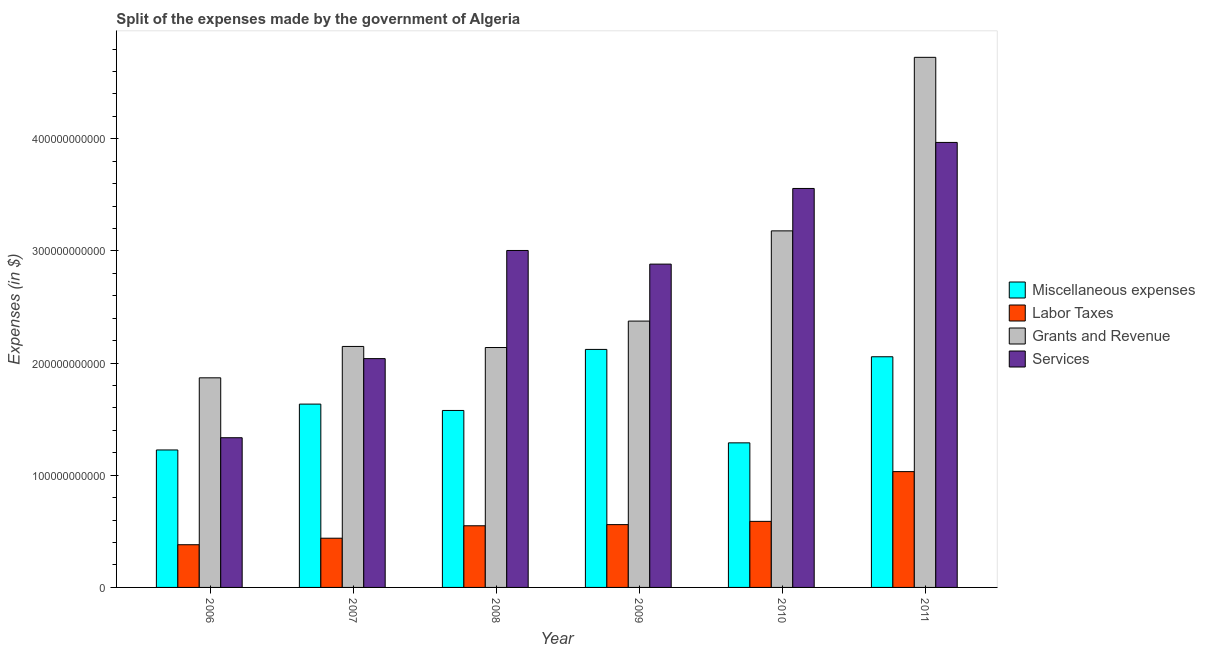How many different coloured bars are there?
Your response must be concise. 4. Are the number of bars per tick equal to the number of legend labels?
Make the answer very short. Yes. How many bars are there on the 5th tick from the left?
Your response must be concise. 4. What is the amount spent on labor taxes in 2008?
Your answer should be very brief. 5.50e+1. Across all years, what is the maximum amount spent on labor taxes?
Offer a terse response. 1.03e+11. Across all years, what is the minimum amount spent on grants and revenue?
Provide a short and direct response. 1.87e+11. What is the total amount spent on services in the graph?
Provide a short and direct response. 1.68e+12. What is the difference between the amount spent on miscellaneous expenses in 2008 and that in 2011?
Your answer should be very brief. -4.79e+1. What is the difference between the amount spent on labor taxes in 2008 and the amount spent on services in 2009?
Give a very brief answer. -1.03e+09. What is the average amount spent on services per year?
Make the answer very short. 2.80e+11. In how many years, is the amount spent on labor taxes greater than 220000000000 $?
Ensure brevity in your answer.  0. What is the ratio of the amount spent on labor taxes in 2007 to that in 2011?
Keep it short and to the point. 0.43. Is the difference between the amount spent on labor taxes in 2007 and 2009 greater than the difference between the amount spent on miscellaneous expenses in 2007 and 2009?
Your response must be concise. No. What is the difference between the highest and the second highest amount spent on grants and revenue?
Your answer should be very brief. 1.55e+11. What is the difference between the highest and the lowest amount spent on labor taxes?
Give a very brief answer. 6.52e+1. What does the 2nd bar from the left in 2010 represents?
Give a very brief answer. Labor Taxes. What does the 3rd bar from the right in 2006 represents?
Keep it short and to the point. Labor Taxes. Is it the case that in every year, the sum of the amount spent on miscellaneous expenses and amount spent on labor taxes is greater than the amount spent on grants and revenue?
Your answer should be very brief. No. Are all the bars in the graph horizontal?
Offer a very short reply. No. How many years are there in the graph?
Provide a succinct answer. 6. What is the difference between two consecutive major ticks on the Y-axis?
Keep it short and to the point. 1.00e+11. Where does the legend appear in the graph?
Offer a terse response. Center right. What is the title of the graph?
Make the answer very short. Split of the expenses made by the government of Algeria. Does "Argument" appear as one of the legend labels in the graph?
Offer a terse response. No. What is the label or title of the Y-axis?
Your answer should be compact. Expenses (in $). What is the Expenses (in $) in Miscellaneous expenses in 2006?
Your response must be concise. 1.23e+11. What is the Expenses (in $) of Labor Taxes in 2006?
Offer a terse response. 3.81e+1. What is the Expenses (in $) of Grants and Revenue in 2006?
Give a very brief answer. 1.87e+11. What is the Expenses (in $) of Services in 2006?
Keep it short and to the point. 1.33e+11. What is the Expenses (in $) of Miscellaneous expenses in 2007?
Offer a terse response. 1.63e+11. What is the Expenses (in $) of Labor Taxes in 2007?
Offer a very short reply. 4.39e+1. What is the Expenses (in $) in Grants and Revenue in 2007?
Give a very brief answer. 2.15e+11. What is the Expenses (in $) of Services in 2007?
Provide a succinct answer. 2.04e+11. What is the Expenses (in $) of Miscellaneous expenses in 2008?
Offer a very short reply. 1.58e+11. What is the Expenses (in $) of Labor Taxes in 2008?
Your response must be concise. 5.50e+1. What is the Expenses (in $) of Grants and Revenue in 2008?
Provide a succinct answer. 2.14e+11. What is the Expenses (in $) in Services in 2008?
Give a very brief answer. 3.00e+11. What is the Expenses (in $) in Miscellaneous expenses in 2009?
Your answer should be compact. 2.12e+11. What is the Expenses (in $) of Labor Taxes in 2009?
Ensure brevity in your answer.  5.60e+1. What is the Expenses (in $) in Grants and Revenue in 2009?
Your answer should be compact. 2.37e+11. What is the Expenses (in $) in Services in 2009?
Offer a very short reply. 2.88e+11. What is the Expenses (in $) in Miscellaneous expenses in 2010?
Keep it short and to the point. 1.29e+11. What is the Expenses (in $) of Labor Taxes in 2010?
Your response must be concise. 5.89e+1. What is the Expenses (in $) of Grants and Revenue in 2010?
Provide a short and direct response. 3.18e+11. What is the Expenses (in $) of Services in 2010?
Your answer should be compact. 3.56e+11. What is the Expenses (in $) in Miscellaneous expenses in 2011?
Offer a very short reply. 2.06e+11. What is the Expenses (in $) in Labor Taxes in 2011?
Give a very brief answer. 1.03e+11. What is the Expenses (in $) of Grants and Revenue in 2011?
Provide a short and direct response. 4.73e+11. What is the Expenses (in $) of Services in 2011?
Make the answer very short. 3.97e+11. Across all years, what is the maximum Expenses (in $) in Miscellaneous expenses?
Your answer should be compact. 2.12e+11. Across all years, what is the maximum Expenses (in $) of Labor Taxes?
Offer a very short reply. 1.03e+11. Across all years, what is the maximum Expenses (in $) of Grants and Revenue?
Give a very brief answer. 4.73e+11. Across all years, what is the maximum Expenses (in $) in Services?
Keep it short and to the point. 3.97e+11. Across all years, what is the minimum Expenses (in $) of Miscellaneous expenses?
Make the answer very short. 1.23e+11. Across all years, what is the minimum Expenses (in $) in Labor Taxes?
Your answer should be compact. 3.81e+1. Across all years, what is the minimum Expenses (in $) of Grants and Revenue?
Provide a succinct answer. 1.87e+11. Across all years, what is the minimum Expenses (in $) of Services?
Make the answer very short. 1.33e+11. What is the total Expenses (in $) of Miscellaneous expenses in the graph?
Offer a terse response. 9.91e+11. What is the total Expenses (in $) of Labor Taxes in the graph?
Ensure brevity in your answer.  3.55e+11. What is the total Expenses (in $) in Grants and Revenue in the graph?
Your response must be concise. 1.64e+12. What is the total Expenses (in $) of Services in the graph?
Provide a short and direct response. 1.68e+12. What is the difference between the Expenses (in $) in Miscellaneous expenses in 2006 and that in 2007?
Offer a very short reply. -4.09e+1. What is the difference between the Expenses (in $) of Labor Taxes in 2006 and that in 2007?
Offer a terse response. -5.81e+09. What is the difference between the Expenses (in $) in Grants and Revenue in 2006 and that in 2007?
Your answer should be compact. -2.80e+1. What is the difference between the Expenses (in $) in Services in 2006 and that in 2007?
Provide a succinct answer. -7.05e+1. What is the difference between the Expenses (in $) of Miscellaneous expenses in 2006 and that in 2008?
Offer a very short reply. -3.52e+1. What is the difference between the Expenses (in $) in Labor Taxes in 2006 and that in 2008?
Keep it short and to the point. -1.69e+1. What is the difference between the Expenses (in $) of Grants and Revenue in 2006 and that in 2008?
Give a very brief answer. -2.70e+1. What is the difference between the Expenses (in $) in Services in 2006 and that in 2008?
Offer a terse response. -1.67e+11. What is the difference between the Expenses (in $) in Miscellaneous expenses in 2006 and that in 2009?
Give a very brief answer. -8.96e+1. What is the difference between the Expenses (in $) in Labor Taxes in 2006 and that in 2009?
Offer a terse response. -1.79e+1. What is the difference between the Expenses (in $) of Grants and Revenue in 2006 and that in 2009?
Keep it short and to the point. -5.06e+1. What is the difference between the Expenses (in $) of Services in 2006 and that in 2009?
Keep it short and to the point. -1.55e+11. What is the difference between the Expenses (in $) of Miscellaneous expenses in 2006 and that in 2010?
Keep it short and to the point. -6.34e+09. What is the difference between the Expenses (in $) in Labor Taxes in 2006 and that in 2010?
Keep it short and to the point. -2.08e+1. What is the difference between the Expenses (in $) of Grants and Revenue in 2006 and that in 2010?
Offer a terse response. -1.31e+11. What is the difference between the Expenses (in $) of Services in 2006 and that in 2010?
Give a very brief answer. -2.22e+11. What is the difference between the Expenses (in $) of Miscellaneous expenses in 2006 and that in 2011?
Your answer should be compact. -8.31e+1. What is the difference between the Expenses (in $) in Labor Taxes in 2006 and that in 2011?
Provide a succinct answer. -6.52e+1. What is the difference between the Expenses (in $) in Grants and Revenue in 2006 and that in 2011?
Your response must be concise. -2.86e+11. What is the difference between the Expenses (in $) of Services in 2006 and that in 2011?
Give a very brief answer. -2.63e+11. What is the difference between the Expenses (in $) in Miscellaneous expenses in 2007 and that in 2008?
Offer a very short reply. 5.66e+09. What is the difference between the Expenses (in $) of Labor Taxes in 2007 and that in 2008?
Ensure brevity in your answer.  -1.11e+1. What is the difference between the Expenses (in $) in Grants and Revenue in 2007 and that in 2008?
Provide a succinct answer. 9.60e+08. What is the difference between the Expenses (in $) of Services in 2007 and that in 2008?
Your response must be concise. -9.64e+1. What is the difference between the Expenses (in $) in Miscellaneous expenses in 2007 and that in 2009?
Your answer should be compact. -4.88e+1. What is the difference between the Expenses (in $) of Labor Taxes in 2007 and that in 2009?
Keep it short and to the point. -1.21e+1. What is the difference between the Expenses (in $) of Grants and Revenue in 2007 and that in 2009?
Offer a very short reply. -2.26e+1. What is the difference between the Expenses (in $) of Services in 2007 and that in 2009?
Provide a succinct answer. -8.43e+1. What is the difference between the Expenses (in $) in Miscellaneous expenses in 2007 and that in 2010?
Give a very brief answer. 3.45e+1. What is the difference between the Expenses (in $) of Labor Taxes in 2007 and that in 2010?
Make the answer very short. -1.50e+1. What is the difference between the Expenses (in $) of Grants and Revenue in 2007 and that in 2010?
Your answer should be compact. -1.03e+11. What is the difference between the Expenses (in $) in Services in 2007 and that in 2010?
Your answer should be compact. -1.52e+11. What is the difference between the Expenses (in $) of Miscellaneous expenses in 2007 and that in 2011?
Your answer should be very brief. -4.22e+1. What is the difference between the Expenses (in $) in Labor Taxes in 2007 and that in 2011?
Offer a very short reply. -5.94e+1. What is the difference between the Expenses (in $) of Grants and Revenue in 2007 and that in 2011?
Your answer should be very brief. -2.58e+11. What is the difference between the Expenses (in $) of Services in 2007 and that in 2011?
Offer a terse response. -1.93e+11. What is the difference between the Expenses (in $) in Miscellaneous expenses in 2008 and that in 2009?
Provide a short and direct response. -5.44e+1. What is the difference between the Expenses (in $) of Labor Taxes in 2008 and that in 2009?
Ensure brevity in your answer.  -1.03e+09. What is the difference between the Expenses (in $) of Grants and Revenue in 2008 and that in 2009?
Offer a very short reply. -2.36e+1. What is the difference between the Expenses (in $) of Services in 2008 and that in 2009?
Offer a very short reply. 1.22e+1. What is the difference between the Expenses (in $) of Miscellaneous expenses in 2008 and that in 2010?
Give a very brief answer. 2.89e+1. What is the difference between the Expenses (in $) in Labor Taxes in 2008 and that in 2010?
Provide a succinct answer. -3.93e+09. What is the difference between the Expenses (in $) of Grants and Revenue in 2008 and that in 2010?
Make the answer very short. -1.04e+11. What is the difference between the Expenses (in $) of Services in 2008 and that in 2010?
Offer a terse response. -5.53e+1. What is the difference between the Expenses (in $) of Miscellaneous expenses in 2008 and that in 2011?
Ensure brevity in your answer.  -4.79e+1. What is the difference between the Expenses (in $) in Labor Taxes in 2008 and that in 2011?
Your answer should be very brief. -4.83e+1. What is the difference between the Expenses (in $) of Grants and Revenue in 2008 and that in 2011?
Give a very brief answer. -2.59e+11. What is the difference between the Expenses (in $) of Services in 2008 and that in 2011?
Provide a succinct answer. -9.63e+1. What is the difference between the Expenses (in $) of Miscellaneous expenses in 2009 and that in 2010?
Give a very brief answer. 8.33e+1. What is the difference between the Expenses (in $) in Labor Taxes in 2009 and that in 2010?
Keep it short and to the point. -2.90e+09. What is the difference between the Expenses (in $) of Grants and Revenue in 2009 and that in 2010?
Your answer should be very brief. -8.04e+1. What is the difference between the Expenses (in $) of Services in 2009 and that in 2010?
Keep it short and to the point. -6.74e+1. What is the difference between the Expenses (in $) of Miscellaneous expenses in 2009 and that in 2011?
Your response must be concise. 6.55e+09. What is the difference between the Expenses (in $) in Labor Taxes in 2009 and that in 2011?
Offer a very short reply. -4.72e+1. What is the difference between the Expenses (in $) in Grants and Revenue in 2009 and that in 2011?
Make the answer very short. -2.35e+11. What is the difference between the Expenses (in $) of Services in 2009 and that in 2011?
Your answer should be compact. -1.08e+11. What is the difference between the Expenses (in $) in Miscellaneous expenses in 2010 and that in 2011?
Your response must be concise. -7.68e+1. What is the difference between the Expenses (in $) in Labor Taxes in 2010 and that in 2011?
Provide a short and direct response. -4.43e+1. What is the difference between the Expenses (in $) in Grants and Revenue in 2010 and that in 2011?
Keep it short and to the point. -1.55e+11. What is the difference between the Expenses (in $) of Services in 2010 and that in 2011?
Provide a short and direct response. -4.10e+1. What is the difference between the Expenses (in $) in Miscellaneous expenses in 2006 and the Expenses (in $) in Labor Taxes in 2007?
Offer a terse response. 7.87e+1. What is the difference between the Expenses (in $) of Miscellaneous expenses in 2006 and the Expenses (in $) of Grants and Revenue in 2007?
Provide a succinct answer. -9.23e+1. What is the difference between the Expenses (in $) of Miscellaneous expenses in 2006 and the Expenses (in $) of Services in 2007?
Offer a terse response. -8.14e+1. What is the difference between the Expenses (in $) of Labor Taxes in 2006 and the Expenses (in $) of Grants and Revenue in 2007?
Offer a very short reply. -1.77e+11. What is the difference between the Expenses (in $) of Labor Taxes in 2006 and the Expenses (in $) of Services in 2007?
Give a very brief answer. -1.66e+11. What is the difference between the Expenses (in $) in Grants and Revenue in 2006 and the Expenses (in $) in Services in 2007?
Your answer should be very brief. -1.71e+1. What is the difference between the Expenses (in $) in Miscellaneous expenses in 2006 and the Expenses (in $) in Labor Taxes in 2008?
Offer a terse response. 6.76e+1. What is the difference between the Expenses (in $) of Miscellaneous expenses in 2006 and the Expenses (in $) of Grants and Revenue in 2008?
Your answer should be compact. -9.13e+1. What is the difference between the Expenses (in $) in Miscellaneous expenses in 2006 and the Expenses (in $) in Services in 2008?
Your response must be concise. -1.78e+11. What is the difference between the Expenses (in $) in Labor Taxes in 2006 and the Expenses (in $) in Grants and Revenue in 2008?
Keep it short and to the point. -1.76e+11. What is the difference between the Expenses (in $) in Labor Taxes in 2006 and the Expenses (in $) in Services in 2008?
Your answer should be compact. -2.62e+11. What is the difference between the Expenses (in $) of Grants and Revenue in 2006 and the Expenses (in $) of Services in 2008?
Offer a terse response. -1.14e+11. What is the difference between the Expenses (in $) in Miscellaneous expenses in 2006 and the Expenses (in $) in Labor Taxes in 2009?
Provide a succinct answer. 6.66e+1. What is the difference between the Expenses (in $) of Miscellaneous expenses in 2006 and the Expenses (in $) of Grants and Revenue in 2009?
Your answer should be compact. -1.15e+11. What is the difference between the Expenses (in $) of Miscellaneous expenses in 2006 and the Expenses (in $) of Services in 2009?
Your answer should be compact. -1.66e+11. What is the difference between the Expenses (in $) of Labor Taxes in 2006 and the Expenses (in $) of Grants and Revenue in 2009?
Give a very brief answer. -1.99e+11. What is the difference between the Expenses (in $) in Labor Taxes in 2006 and the Expenses (in $) in Services in 2009?
Provide a short and direct response. -2.50e+11. What is the difference between the Expenses (in $) in Grants and Revenue in 2006 and the Expenses (in $) in Services in 2009?
Make the answer very short. -1.01e+11. What is the difference between the Expenses (in $) in Miscellaneous expenses in 2006 and the Expenses (in $) in Labor Taxes in 2010?
Provide a short and direct response. 6.37e+1. What is the difference between the Expenses (in $) of Miscellaneous expenses in 2006 and the Expenses (in $) of Grants and Revenue in 2010?
Your answer should be compact. -1.95e+11. What is the difference between the Expenses (in $) of Miscellaneous expenses in 2006 and the Expenses (in $) of Services in 2010?
Offer a terse response. -2.33e+11. What is the difference between the Expenses (in $) of Labor Taxes in 2006 and the Expenses (in $) of Grants and Revenue in 2010?
Give a very brief answer. -2.80e+11. What is the difference between the Expenses (in $) in Labor Taxes in 2006 and the Expenses (in $) in Services in 2010?
Provide a short and direct response. -3.18e+11. What is the difference between the Expenses (in $) of Grants and Revenue in 2006 and the Expenses (in $) of Services in 2010?
Your response must be concise. -1.69e+11. What is the difference between the Expenses (in $) in Miscellaneous expenses in 2006 and the Expenses (in $) in Labor Taxes in 2011?
Your answer should be very brief. 1.93e+1. What is the difference between the Expenses (in $) of Miscellaneous expenses in 2006 and the Expenses (in $) of Grants and Revenue in 2011?
Your answer should be very brief. -3.50e+11. What is the difference between the Expenses (in $) of Miscellaneous expenses in 2006 and the Expenses (in $) of Services in 2011?
Give a very brief answer. -2.74e+11. What is the difference between the Expenses (in $) in Labor Taxes in 2006 and the Expenses (in $) in Grants and Revenue in 2011?
Your response must be concise. -4.35e+11. What is the difference between the Expenses (in $) in Labor Taxes in 2006 and the Expenses (in $) in Services in 2011?
Make the answer very short. -3.59e+11. What is the difference between the Expenses (in $) of Grants and Revenue in 2006 and the Expenses (in $) of Services in 2011?
Your answer should be compact. -2.10e+11. What is the difference between the Expenses (in $) of Miscellaneous expenses in 2007 and the Expenses (in $) of Labor Taxes in 2008?
Your answer should be compact. 1.08e+11. What is the difference between the Expenses (in $) of Miscellaneous expenses in 2007 and the Expenses (in $) of Grants and Revenue in 2008?
Make the answer very short. -5.04e+1. What is the difference between the Expenses (in $) of Miscellaneous expenses in 2007 and the Expenses (in $) of Services in 2008?
Ensure brevity in your answer.  -1.37e+11. What is the difference between the Expenses (in $) in Labor Taxes in 2007 and the Expenses (in $) in Grants and Revenue in 2008?
Provide a short and direct response. -1.70e+11. What is the difference between the Expenses (in $) in Labor Taxes in 2007 and the Expenses (in $) in Services in 2008?
Give a very brief answer. -2.57e+11. What is the difference between the Expenses (in $) in Grants and Revenue in 2007 and the Expenses (in $) in Services in 2008?
Keep it short and to the point. -8.56e+1. What is the difference between the Expenses (in $) of Miscellaneous expenses in 2007 and the Expenses (in $) of Labor Taxes in 2009?
Provide a short and direct response. 1.07e+11. What is the difference between the Expenses (in $) of Miscellaneous expenses in 2007 and the Expenses (in $) of Grants and Revenue in 2009?
Provide a short and direct response. -7.40e+1. What is the difference between the Expenses (in $) in Miscellaneous expenses in 2007 and the Expenses (in $) in Services in 2009?
Your response must be concise. -1.25e+11. What is the difference between the Expenses (in $) of Labor Taxes in 2007 and the Expenses (in $) of Grants and Revenue in 2009?
Your answer should be compact. -1.94e+11. What is the difference between the Expenses (in $) of Labor Taxes in 2007 and the Expenses (in $) of Services in 2009?
Offer a terse response. -2.44e+11. What is the difference between the Expenses (in $) of Grants and Revenue in 2007 and the Expenses (in $) of Services in 2009?
Offer a very short reply. -7.34e+1. What is the difference between the Expenses (in $) of Miscellaneous expenses in 2007 and the Expenses (in $) of Labor Taxes in 2010?
Ensure brevity in your answer.  1.05e+11. What is the difference between the Expenses (in $) in Miscellaneous expenses in 2007 and the Expenses (in $) in Grants and Revenue in 2010?
Your response must be concise. -1.54e+11. What is the difference between the Expenses (in $) in Miscellaneous expenses in 2007 and the Expenses (in $) in Services in 2010?
Provide a succinct answer. -1.92e+11. What is the difference between the Expenses (in $) in Labor Taxes in 2007 and the Expenses (in $) in Grants and Revenue in 2010?
Offer a very short reply. -2.74e+11. What is the difference between the Expenses (in $) in Labor Taxes in 2007 and the Expenses (in $) in Services in 2010?
Your response must be concise. -3.12e+11. What is the difference between the Expenses (in $) in Grants and Revenue in 2007 and the Expenses (in $) in Services in 2010?
Your answer should be very brief. -1.41e+11. What is the difference between the Expenses (in $) in Miscellaneous expenses in 2007 and the Expenses (in $) in Labor Taxes in 2011?
Provide a short and direct response. 6.02e+1. What is the difference between the Expenses (in $) in Miscellaneous expenses in 2007 and the Expenses (in $) in Grants and Revenue in 2011?
Ensure brevity in your answer.  -3.09e+11. What is the difference between the Expenses (in $) in Miscellaneous expenses in 2007 and the Expenses (in $) in Services in 2011?
Keep it short and to the point. -2.33e+11. What is the difference between the Expenses (in $) of Labor Taxes in 2007 and the Expenses (in $) of Grants and Revenue in 2011?
Provide a succinct answer. -4.29e+11. What is the difference between the Expenses (in $) in Labor Taxes in 2007 and the Expenses (in $) in Services in 2011?
Provide a short and direct response. -3.53e+11. What is the difference between the Expenses (in $) of Grants and Revenue in 2007 and the Expenses (in $) of Services in 2011?
Make the answer very short. -1.82e+11. What is the difference between the Expenses (in $) of Miscellaneous expenses in 2008 and the Expenses (in $) of Labor Taxes in 2009?
Give a very brief answer. 1.02e+11. What is the difference between the Expenses (in $) in Miscellaneous expenses in 2008 and the Expenses (in $) in Grants and Revenue in 2009?
Keep it short and to the point. -7.97e+1. What is the difference between the Expenses (in $) of Miscellaneous expenses in 2008 and the Expenses (in $) of Services in 2009?
Provide a short and direct response. -1.30e+11. What is the difference between the Expenses (in $) in Labor Taxes in 2008 and the Expenses (in $) in Grants and Revenue in 2009?
Your answer should be very brief. -1.82e+11. What is the difference between the Expenses (in $) in Labor Taxes in 2008 and the Expenses (in $) in Services in 2009?
Provide a succinct answer. -2.33e+11. What is the difference between the Expenses (in $) in Grants and Revenue in 2008 and the Expenses (in $) in Services in 2009?
Keep it short and to the point. -7.44e+1. What is the difference between the Expenses (in $) in Miscellaneous expenses in 2008 and the Expenses (in $) in Labor Taxes in 2010?
Your response must be concise. 9.89e+1. What is the difference between the Expenses (in $) in Miscellaneous expenses in 2008 and the Expenses (in $) in Grants and Revenue in 2010?
Give a very brief answer. -1.60e+11. What is the difference between the Expenses (in $) of Miscellaneous expenses in 2008 and the Expenses (in $) of Services in 2010?
Offer a very short reply. -1.98e+11. What is the difference between the Expenses (in $) in Labor Taxes in 2008 and the Expenses (in $) in Grants and Revenue in 2010?
Your answer should be compact. -2.63e+11. What is the difference between the Expenses (in $) of Labor Taxes in 2008 and the Expenses (in $) of Services in 2010?
Provide a succinct answer. -3.01e+11. What is the difference between the Expenses (in $) of Grants and Revenue in 2008 and the Expenses (in $) of Services in 2010?
Provide a succinct answer. -1.42e+11. What is the difference between the Expenses (in $) in Miscellaneous expenses in 2008 and the Expenses (in $) in Labor Taxes in 2011?
Give a very brief answer. 5.45e+1. What is the difference between the Expenses (in $) in Miscellaneous expenses in 2008 and the Expenses (in $) in Grants and Revenue in 2011?
Give a very brief answer. -3.15e+11. What is the difference between the Expenses (in $) in Miscellaneous expenses in 2008 and the Expenses (in $) in Services in 2011?
Make the answer very short. -2.39e+11. What is the difference between the Expenses (in $) in Labor Taxes in 2008 and the Expenses (in $) in Grants and Revenue in 2011?
Ensure brevity in your answer.  -4.18e+11. What is the difference between the Expenses (in $) in Labor Taxes in 2008 and the Expenses (in $) in Services in 2011?
Offer a terse response. -3.42e+11. What is the difference between the Expenses (in $) in Grants and Revenue in 2008 and the Expenses (in $) in Services in 2011?
Offer a terse response. -1.83e+11. What is the difference between the Expenses (in $) of Miscellaneous expenses in 2009 and the Expenses (in $) of Labor Taxes in 2010?
Keep it short and to the point. 1.53e+11. What is the difference between the Expenses (in $) of Miscellaneous expenses in 2009 and the Expenses (in $) of Grants and Revenue in 2010?
Keep it short and to the point. -1.06e+11. What is the difference between the Expenses (in $) of Miscellaneous expenses in 2009 and the Expenses (in $) of Services in 2010?
Provide a succinct answer. -1.43e+11. What is the difference between the Expenses (in $) in Labor Taxes in 2009 and the Expenses (in $) in Grants and Revenue in 2010?
Give a very brief answer. -2.62e+11. What is the difference between the Expenses (in $) of Labor Taxes in 2009 and the Expenses (in $) of Services in 2010?
Offer a terse response. -3.00e+11. What is the difference between the Expenses (in $) of Grants and Revenue in 2009 and the Expenses (in $) of Services in 2010?
Your answer should be very brief. -1.18e+11. What is the difference between the Expenses (in $) in Miscellaneous expenses in 2009 and the Expenses (in $) in Labor Taxes in 2011?
Provide a short and direct response. 1.09e+11. What is the difference between the Expenses (in $) of Miscellaneous expenses in 2009 and the Expenses (in $) of Grants and Revenue in 2011?
Your response must be concise. -2.60e+11. What is the difference between the Expenses (in $) in Miscellaneous expenses in 2009 and the Expenses (in $) in Services in 2011?
Offer a terse response. -1.85e+11. What is the difference between the Expenses (in $) in Labor Taxes in 2009 and the Expenses (in $) in Grants and Revenue in 2011?
Give a very brief answer. -4.17e+11. What is the difference between the Expenses (in $) of Labor Taxes in 2009 and the Expenses (in $) of Services in 2011?
Make the answer very short. -3.41e+11. What is the difference between the Expenses (in $) in Grants and Revenue in 2009 and the Expenses (in $) in Services in 2011?
Your response must be concise. -1.59e+11. What is the difference between the Expenses (in $) in Miscellaneous expenses in 2010 and the Expenses (in $) in Labor Taxes in 2011?
Keep it short and to the point. 2.57e+1. What is the difference between the Expenses (in $) of Miscellaneous expenses in 2010 and the Expenses (in $) of Grants and Revenue in 2011?
Keep it short and to the point. -3.44e+11. What is the difference between the Expenses (in $) in Miscellaneous expenses in 2010 and the Expenses (in $) in Services in 2011?
Your answer should be compact. -2.68e+11. What is the difference between the Expenses (in $) of Labor Taxes in 2010 and the Expenses (in $) of Grants and Revenue in 2011?
Provide a succinct answer. -4.14e+11. What is the difference between the Expenses (in $) in Labor Taxes in 2010 and the Expenses (in $) in Services in 2011?
Provide a short and direct response. -3.38e+11. What is the difference between the Expenses (in $) in Grants and Revenue in 2010 and the Expenses (in $) in Services in 2011?
Give a very brief answer. -7.88e+1. What is the average Expenses (in $) of Miscellaneous expenses per year?
Offer a terse response. 1.65e+11. What is the average Expenses (in $) of Labor Taxes per year?
Keep it short and to the point. 5.92e+1. What is the average Expenses (in $) in Grants and Revenue per year?
Give a very brief answer. 2.74e+11. What is the average Expenses (in $) in Services per year?
Give a very brief answer. 2.80e+11. In the year 2006, what is the difference between the Expenses (in $) of Miscellaneous expenses and Expenses (in $) of Labor Taxes?
Your answer should be very brief. 8.45e+1. In the year 2006, what is the difference between the Expenses (in $) of Miscellaneous expenses and Expenses (in $) of Grants and Revenue?
Offer a very short reply. -6.43e+1. In the year 2006, what is the difference between the Expenses (in $) in Miscellaneous expenses and Expenses (in $) in Services?
Give a very brief answer. -1.09e+1. In the year 2006, what is the difference between the Expenses (in $) of Labor Taxes and Expenses (in $) of Grants and Revenue?
Give a very brief answer. -1.49e+11. In the year 2006, what is the difference between the Expenses (in $) in Labor Taxes and Expenses (in $) in Services?
Offer a terse response. -9.54e+1. In the year 2006, what is the difference between the Expenses (in $) of Grants and Revenue and Expenses (in $) of Services?
Offer a very short reply. 5.34e+1. In the year 2007, what is the difference between the Expenses (in $) of Miscellaneous expenses and Expenses (in $) of Labor Taxes?
Offer a very short reply. 1.20e+11. In the year 2007, what is the difference between the Expenses (in $) in Miscellaneous expenses and Expenses (in $) in Grants and Revenue?
Ensure brevity in your answer.  -5.14e+1. In the year 2007, what is the difference between the Expenses (in $) in Miscellaneous expenses and Expenses (in $) in Services?
Offer a very short reply. -4.06e+1. In the year 2007, what is the difference between the Expenses (in $) in Labor Taxes and Expenses (in $) in Grants and Revenue?
Your answer should be very brief. -1.71e+11. In the year 2007, what is the difference between the Expenses (in $) in Labor Taxes and Expenses (in $) in Services?
Ensure brevity in your answer.  -1.60e+11. In the year 2007, what is the difference between the Expenses (in $) of Grants and Revenue and Expenses (in $) of Services?
Offer a terse response. 1.08e+1. In the year 2008, what is the difference between the Expenses (in $) of Miscellaneous expenses and Expenses (in $) of Labor Taxes?
Give a very brief answer. 1.03e+11. In the year 2008, what is the difference between the Expenses (in $) in Miscellaneous expenses and Expenses (in $) in Grants and Revenue?
Make the answer very short. -5.61e+1. In the year 2008, what is the difference between the Expenses (in $) of Miscellaneous expenses and Expenses (in $) of Services?
Ensure brevity in your answer.  -1.43e+11. In the year 2008, what is the difference between the Expenses (in $) in Labor Taxes and Expenses (in $) in Grants and Revenue?
Provide a succinct answer. -1.59e+11. In the year 2008, what is the difference between the Expenses (in $) of Labor Taxes and Expenses (in $) of Services?
Provide a succinct answer. -2.45e+11. In the year 2008, what is the difference between the Expenses (in $) in Grants and Revenue and Expenses (in $) in Services?
Keep it short and to the point. -8.65e+1. In the year 2009, what is the difference between the Expenses (in $) of Miscellaneous expenses and Expenses (in $) of Labor Taxes?
Keep it short and to the point. 1.56e+11. In the year 2009, what is the difference between the Expenses (in $) of Miscellaneous expenses and Expenses (in $) of Grants and Revenue?
Make the answer very short. -2.52e+1. In the year 2009, what is the difference between the Expenses (in $) in Miscellaneous expenses and Expenses (in $) in Services?
Give a very brief answer. -7.60e+1. In the year 2009, what is the difference between the Expenses (in $) in Labor Taxes and Expenses (in $) in Grants and Revenue?
Your answer should be compact. -1.81e+11. In the year 2009, what is the difference between the Expenses (in $) in Labor Taxes and Expenses (in $) in Services?
Your response must be concise. -2.32e+11. In the year 2009, what is the difference between the Expenses (in $) of Grants and Revenue and Expenses (in $) of Services?
Your response must be concise. -5.08e+1. In the year 2010, what is the difference between the Expenses (in $) in Miscellaneous expenses and Expenses (in $) in Labor Taxes?
Your answer should be compact. 7.00e+1. In the year 2010, what is the difference between the Expenses (in $) in Miscellaneous expenses and Expenses (in $) in Grants and Revenue?
Keep it short and to the point. -1.89e+11. In the year 2010, what is the difference between the Expenses (in $) in Miscellaneous expenses and Expenses (in $) in Services?
Provide a succinct answer. -2.27e+11. In the year 2010, what is the difference between the Expenses (in $) in Labor Taxes and Expenses (in $) in Grants and Revenue?
Your answer should be compact. -2.59e+11. In the year 2010, what is the difference between the Expenses (in $) in Labor Taxes and Expenses (in $) in Services?
Provide a succinct answer. -2.97e+11. In the year 2010, what is the difference between the Expenses (in $) of Grants and Revenue and Expenses (in $) of Services?
Offer a terse response. -3.78e+1. In the year 2011, what is the difference between the Expenses (in $) in Miscellaneous expenses and Expenses (in $) in Labor Taxes?
Make the answer very short. 1.02e+11. In the year 2011, what is the difference between the Expenses (in $) of Miscellaneous expenses and Expenses (in $) of Grants and Revenue?
Provide a short and direct response. -2.67e+11. In the year 2011, what is the difference between the Expenses (in $) of Miscellaneous expenses and Expenses (in $) of Services?
Provide a short and direct response. -1.91e+11. In the year 2011, what is the difference between the Expenses (in $) of Labor Taxes and Expenses (in $) of Grants and Revenue?
Offer a very short reply. -3.69e+11. In the year 2011, what is the difference between the Expenses (in $) of Labor Taxes and Expenses (in $) of Services?
Your answer should be compact. -2.93e+11. In the year 2011, what is the difference between the Expenses (in $) in Grants and Revenue and Expenses (in $) in Services?
Your response must be concise. 7.59e+1. What is the ratio of the Expenses (in $) of Miscellaneous expenses in 2006 to that in 2007?
Ensure brevity in your answer.  0.75. What is the ratio of the Expenses (in $) in Labor Taxes in 2006 to that in 2007?
Make the answer very short. 0.87. What is the ratio of the Expenses (in $) of Grants and Revenue in 2006 to that in 2007?
Ensure brevity in your answer.  0.87. What is the ratio of the Expenses (in $) of Services in 2006 to that in 2007?
Provide a short and direct response. 0.65. What is the ratio of the Expenses (in $) of Miscellaneous expenses in 2006 to that in 2008?
Provide a short and direct response. 0.78. What is the ratio of the Expenses (in $) of Labor Taxes in 2006 to that in 2008?
Your answer should be compact. 0.69. What is the ratio of the Expenses (in $) in Grants and Revenue in 2006 to that in 2008?
Your answer should be very brief. 0.87. What is the ratio of the Expenses (in $) of Services in 2006 to that in 2008?
Your answer should be compact. 0.44. What is the ratio of the Expenses (in $) in Miscellaneous expenses in 2006 to that in 2009?
Offer a very short reply. 0.58. What is the ratio of the Expenses (in $) in Labor Taxes in 2006 to that in 2009?
Keep it short and to the point. 0.68. What is the ratio of the Expenses (in $) of Grants and Revenue in 2006 to that in 2009?
Give a very brief answer. 0.79. What is the ratio of the Expenses (in $) in Services in 2006 to that in 2009?
Your response must be concise. 0.46. What is the ratio of the Expenses (in $) in Miscellaneous expenses in 2006 to that in 2010?
Offer a very short reply. 0.95. What is the ratio of the Expenses (in $) in Labor Taxes in 2006 to that in 2010?
Ensure brevity in your answer.  0.65. What is the ratio of the Expenses (in $) of Grants and Revenue in 2006 to that in 2010?
Keep it short and to the point. 0.59. What is the ratio of the Expenses (in $) in Services in 2006 to that in 2010?
Offer a very short reply. 0.38. What is the ratio of the Expenses (in $) of Miscellaneous expenses in 2006 to that in 2011?
Your answer should be very brief. 0.6. What is the ratio of the Expenses (in $) of Labor Taxes in 2006 to that in 2011?
Ensure brevity in your answer.  0.37. What is the ratio of the Expenses (in $) in Grants and Revenue in 2006 to that in 2011?
Offer a very short reply. 0.4. What is the ratio of the Expenses (in $) of Services in 2006 to that in 2011?
Your answer should be very brief. 0.34. What is the ratio of the Expenses (in $) in Miscellaneous expenses in 2007 to that in 2008?
Keep it short and to the point. 1.04. What is the ratio of the Expenses (in $) in Labor Taxes in 2007 to that in 2008?
Offer a very short reply. 0.8. What is the ratio of the Expenses (in $) in Grants and Revenue in 2007 to that in 2008?
Your answer should be very brief. 1. What is the ratio of the Expenses (in $) in Services in 2007 to that in 2008?
Provide a succinct answer. 0.68. What is the ratio of the Expenses (in $) of Miscellaneous expenses in 2007 to that in 2009?
Offer a terse response. 0.77. What is the ratio of the Expenses (in $) in Labor Taxes in 2007 to that in 2009?
Offer a very short reply. 0.78. What is the ratio of the Expenses (in $) in Grants and Revenue in 2007 to that in 2009?
Your answer should be very brief. 0.9. What is the ratio of the Expenses (in $) of Services in 2007 to that in 2009?
Your response must be concise. 0.71. What is the ratio of the Expenses (in $) in Miscellaneous expenses in 2007 to that in 2010?
Offer a very short reply. 1.27. What is the ratio of the Expenses (in $) in Labor Taxes in 2007 to that in 2010?
Give a very brief answer. 0.74. What is the ratio of the Expenses (in $) of Grants and Revenue in 2007 to that in 2010?
Your answer should be compact. 0.68. What is the ratio of the Expenses (in $) in Services in 2007 to that in 2010?
Ensure brevity in your answer.  0.57. What is the ratio of the Expenses (in $) of Miscellaneous expenses in 2007 to that in 2011?
Provide a succinct answer. 0.79. What is the ratio of the Expenses (in $) of Labor Taxes in 2007 to that in 2011?
Keep it short and to the point. 0.42. What is the ratio of the Expenses (in $) of Grants and Revenue in 2007 to that in 2011?
Keep it short and to the point. 0.45. What is the ratio of the Expenses (in $) in Services in 2007 to that in 2011?
Keep it short and to the point. 0.51. What is the ratio of the Expenses (in $) of Miscellaneous expenses in 2008 to that in 2009?
Your answer should be compact. 0.74. What is the ratio of the Expenses (in $) of Labor Taxes in 2008 to that in 2009?
Provide a short and direct response. 0.98. What is the ratio of the Expenses (in $) of Grants and Revenue in 2008 to that in 2009?
Ensure brevity in your answer.  0.9. What is the ratio of the Expenses (in $) in Services in 2008 to that in 2009?
Offer a very short reply. 1.04. What is the ratio of the Expenses (in $) in Miscellaneous expenses in 2008 to that in 2010?
Give a very brief answer. 1.22. What is the ratio of the Expenses (in $) in Labor Taxes in 2008 to that in 2010?
Offer a terse response. 0.93. What is the ratio of the Expenses (in $) of Grants and Revenue in 2008 to that in 2010?
Your response must be concise. 0.67. What is the ratio of the Expenses (in $) of Services in 2008 to that in 2010?
Offer a very short reply. 0.84. What is the ratio of the Expenses (in $) of Miscellaneous expenses in 2008 to that in 2011?
Keep it short and to the point. 0.77. What is the ratio of the Expenses (in $) in Labor Taxes in 2008 to that in 2011?
Make the answer very short. 0.53. What is the ratio of the Expenses (in $) of Grants and Revenue in 2008 to that in 2011?
Your answer should be compact. 0.45. What is the ratio of the Expenses (in $) in Services in 2008 to that in 2011?
Give a very brief answer. 0.76. What is the ratio of the Expenses (in $) in Miscellaneous expenses in 2009 to that in 2010?
Ensure brevity in your answer.  1.65. What is the ratio of the Expenses (in $) of Labor Taxes in 2009 to that in 2010?
Offer a very short reply. 0.95. What is the ratio of the Expenses (in $) of Grants and Revenue in 2009 to that in 2010?
Your response must be concise. 0.75. What is the ratio of the Expenses (in $) in Services in 2009 to that in 2010?
Ensure brevity in your answer.  0.81. What is the ratio of the Expenses (in $) of Miscellaneous expenses in 2009 to that in 2011?
Provide a short and direct response. 1.03. What is the ratio of the Expenses (in $) of Labor Taxes in 2009 to that in 2011?
Provide a succinct answer. 0.54. What is the ratio of the Expenses (in $) in Grants and Revenue in 2009 to that in 2011?
Your response must be concise. 0.5. What is the ratio of the Expenses (in $) in Services in 2009 to that in 2011?
Your response must be concise. 0.73. What is the ratio of the Expenses (in $) of Miscellaneous expenses in 2010 to that in 2011?
Your answer should be very brief. 0.63. What is the ratio of the Expenses (in $) of Labor Taxes in 2010 to that in 2011?
Provide a short and direct response. 0.57. What is the ratio of the Expenses (in $) in Grants and Revenue in 2010 to that in 2011?
Offer a very short reply. 0.67. What is the ratio of the Expenses (in $) in Services in 2010 to that in 2011?
Your answer should be compact. 0.9. What is the difference between the highest and the second highest Expenses (in $) of Miscellaneous expenses?
Provide a short and direct response. 6.55e+09. What is the difference between the highest and the second highest Expenses (in $) of Labor Taxes?
Your answer should be compact. 4.43e+1. What is the difference between the highest and the second highest Expenses (in $) of Grants and Revenue?
Offer a very short reply. 1.55e+11. What is the difference between the highest and the second highest Expenses (in $) of Services?
Ensure brevity in your answer.  4.10e+1. What is the difference between the highest and the lowest Expenses (in $) in Miscellaneous expenses?
Provide a short and direct response. 8.96e+1. What is the difference between the highest and the lowest Expenses (in $) of Labor Taxes?
Offer a very short reply. 6.52e+1. What is the difference between the highest and the lowest Expenses (in $) of Grants and Revenue?
Offer a very short reply. 2.86e+11. What is the difference between the highest and the lowest Expenses (in $) of Services?
Your answer should be very brief. 2.63e+11. 